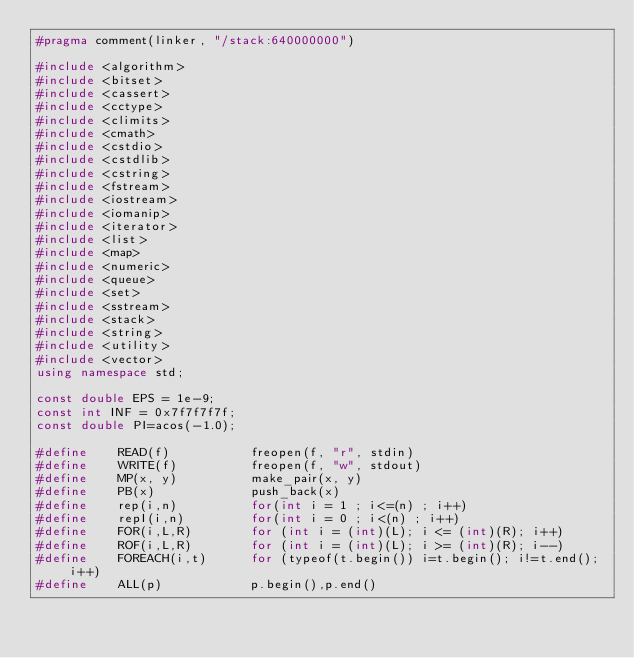Convert code to text. <code><loc_0><loc_0><loc_500><loc_500><_C++_>#pragma comment(linker, "/stack:640000000")

#include <algorithm>
#include <bitset>
#include <cassert>
#include <cctype>
#include <climits>
#include <cmath>
#include <cstdio>
#include <cstdlib>
#include <cstring>
#include <fstream>
#include <iostream>
#include <iomanip>
#include <iterator>
#include <list>
#include <map>
#include <numeric>
#include <queue>
#include <set>
#include <sstream>
#include <stack>
#include <string>
#include <utility>
#include <vector>
using namespace std;

const double EPS = 1e-9;
const int INF = 0x7f7f7f7f;
const double PI=acos(-1.0);

#define    READ(f) 	         freopen(f, "r", stdin)
#define    WRITE(f)   	     freopen(f, "w", stdout)
#define    MP(x, y) 	     make_pair(x, y)
#define    PB(x)             push_back(x)
#define    rep(i,n)          for(int i = 1 ; i<=(n) ; i++)
#define    repI(i,n)         for(int i = 0 ; i<(n) ; i++)
#define    FOR(i,L,R) 	     for (int i = (int)(L); i <= (int)(R); i++)
#define    ROF(i,L,R) 	     for (int i = (int)(L); i >= (int)(R); i--)
#define    FOREACH(i,t)      for (typeof(t.begin()) i=t.begin(); i!=t.end(); i++)
#define    ALL(p) 	         p.begin(),p.end()</code> 